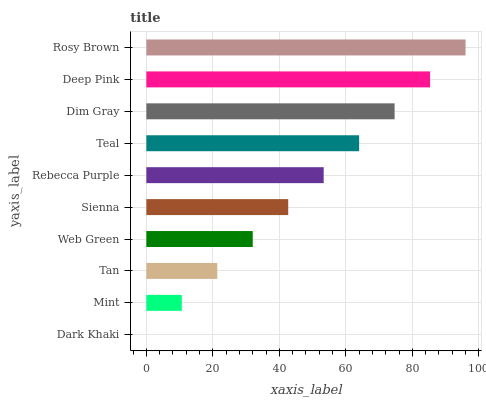Is Dark Khaki the minimum?
Answer yes or no. Yes. Is Rosy Brown the maximum?
Answer yes or no. Yes. Is Mint the minimum?
Answer yes or no. No. Is Mint the maximum?
Answer yes or no. No. Is Mint greater than Dark Khaki?
Answer yes or no. Yes. Is Dark Khaki less than Mint?
Answer yes or no. Yes. Is Dark Khaki greater than Mint?
Answer yes or no. No. Is Mint less than Dark Khaki?
Answer yes or no. No. Is Rebecca Purple the high median?
Answer yes or no. Yes. Is Sienna the low median?
Answer yes or no. Yes. Is Mint the high median?
Answer yes or no. No. Is Rebecca Purple the low median?
Answer yes or no. No. 